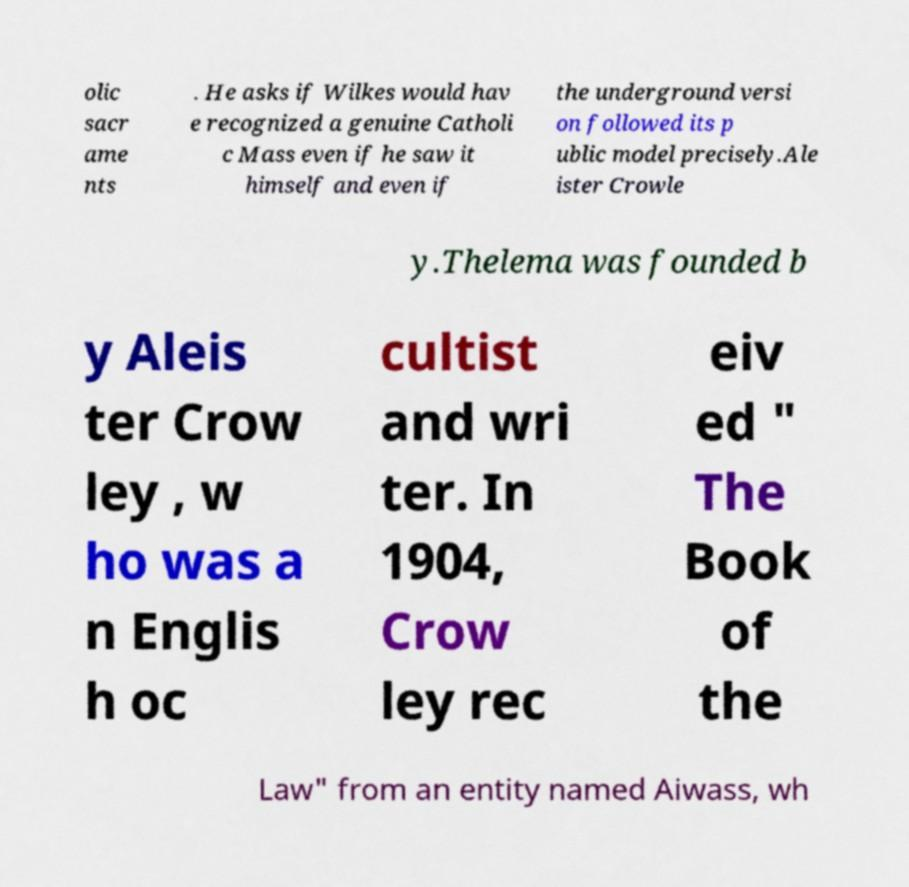Could you extract and type out the text from this image? olic sacr ame nts . He asks if Wilkes would hav e recognized a genuine Catholi c Mass even if he saw it himself and even if the underground versi on followed its p ublic model precisely.Ale ister Crowle y.Thelema was founded b y Aleis ter Crow ley , w ho was a n Englis h oc cultist and wri ter. In 1904, Crow ley rec eiv ed " The Book of the Law" from an entity named Aiwass, wh 